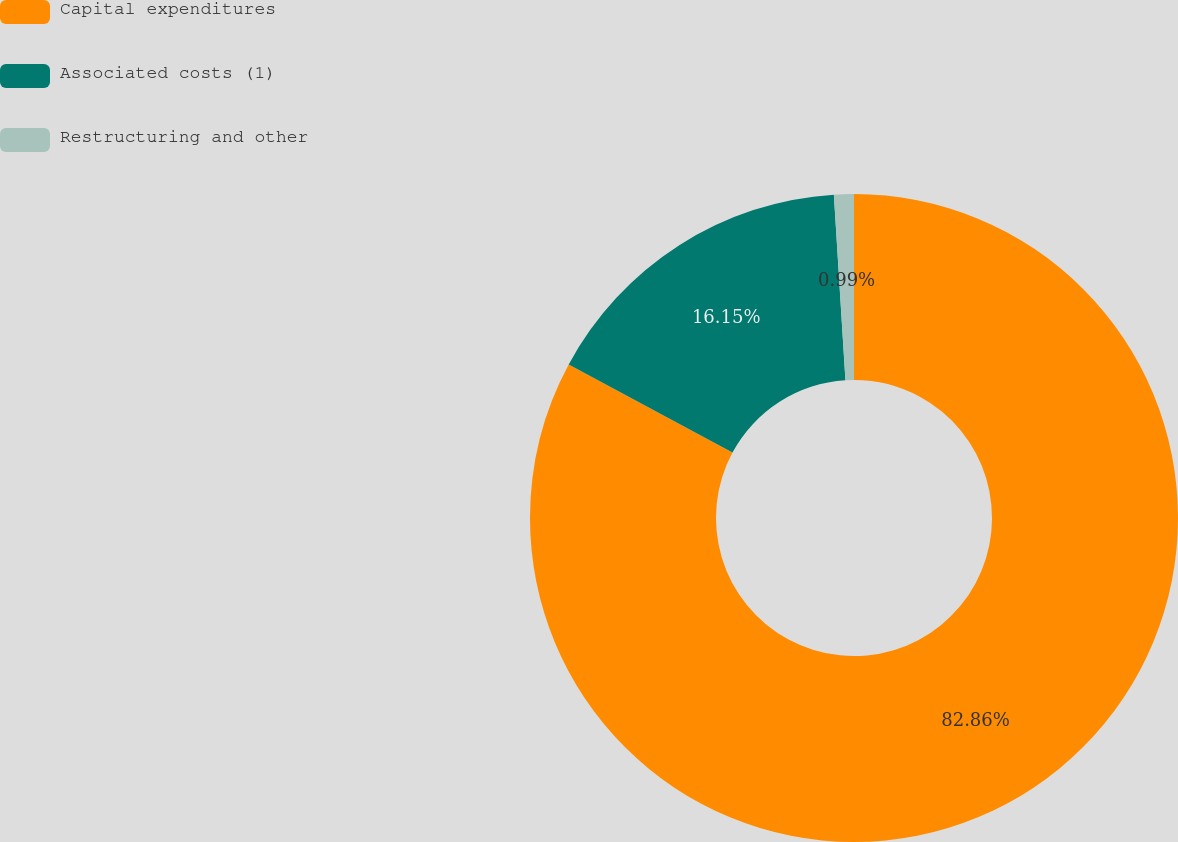<chart> <loc_0><loc_0><loc_500><loc_500><pie_chart><fcel>Capital expenditures<fcel>Associated costs (1)<fcel>Restructuring and other<nl><fcel>82.86%<fcel>16.15%<fcel>0.99%<nl></chart> 